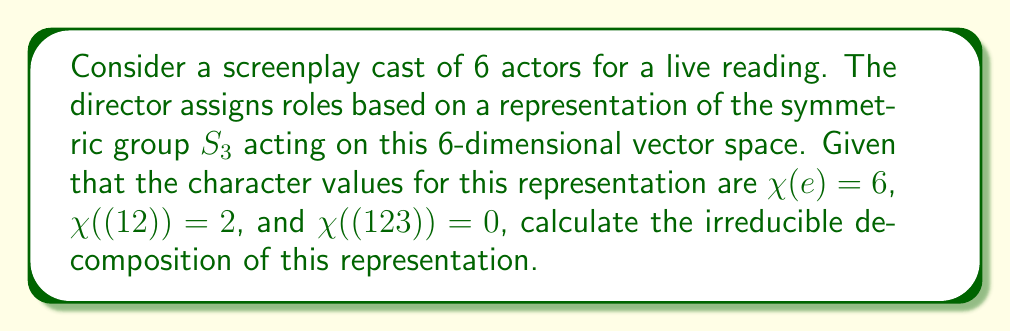Can you solve this math problem? To find the irreducible decomposition, we'll follow these steps:

1) Recall the irreducible representations of $S_3$:
   - Trivial representation: $\chi_1 = [1, 1, 1]$
   - Sign representation: $\chi_2 = [1, -1, 1]$
   - Standard representation: $\chi_3 = [2, 0, -1]$

2) Let our representation be $\rho$. We need to find $a$, $b$, and $c$ such that:
   $\rho = a\chi_1 \oplus b\chi_2 \oplus c\chi_3$

3) Use the inner product formula:
   $\langle \chi_\rho, \chi_i \rangle = \frac{1}{|G|}\sum_{g \in G} \chi_\rho(g)\overline{\chi_i(g)}$

4) Calculate for each irreducible representation:

   For $\chi_1$:
   $a = \langle \chi_\rho, \chi_1 \rangle = \frac{1}{6}(6 \cdot 1 + 3 \cdot 2 \cdot 1 + 2 \cdot 0 \cdot 1) = 2$

   For $\chi_2$:
   $b = \langle \chi_\rho, \chi_2 \rangle = \frac{1}{6}(6 \cdot 1 + 3 \cdot 2 \cdot (-1) + 2 \cdot 0 \cdot 1) = 0$

   For $\chi_3$:
   $c = \langle \chi_\rho, \chi_3 \rangle = \frac{1}{6}(6 \cdot 2 + 3 \cdot 2 \cdot 0 + 2 \cdot 0 \cdot (-1)) = 2$

5) Therefore, the irreducible decomposition is:
   $\rho = 2\chi_1 \oplus 0\chi_2 \oplus 2\chi_3$

This means the representation decomposes into two copies of the trivial representation and two copies of the standard representation.
Answer: $2\chi_1 \oplus 2\chi_3$ 